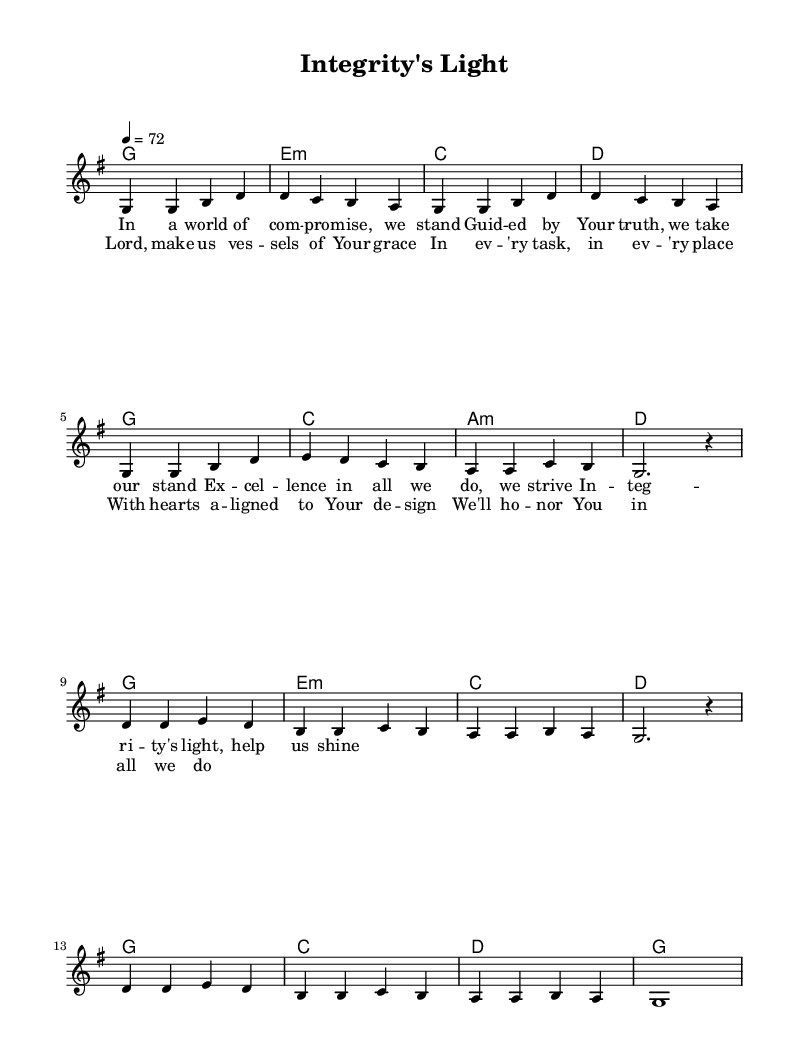What is the key signature of this music? The key signature is G major, which has one sharp (F#).
Answer: G major What is the time signature of this music? The time signature is 4/4, meaning there are four beats in each measure.
Answer: 4/4 What is the tempo marking for this piece? The tempo marking is 72 beats per minute, indicating how fast the music should be played.
Answer: 72 How many verses are indicated in the lyrics? The lyrics provided include one verse and a chorus, typically denoting a single verse structure.
Answer: One In which line of the chorus do the words "honor You" appear? "Honor You" appears in the fourth line of the chorus, indicating the focus on reverence.
Answer: Fourth line What musical form does this piece primarily follow based on the sections described? The piece follows a verse-chorus structure, common in modern worship songs where thematic content is emphasized.
Answer: Verse-chorus What is the overall theme of the lyrics portrayed in this music? The overall theme of the lyrics emphasizes professional integrity and striving for excellence in every task.
Answer: Professional integrity and excellence 